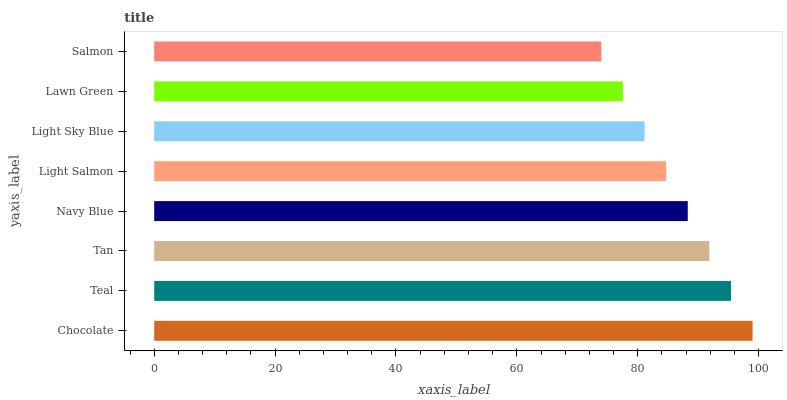Is Salmon the minimum?
Answer yes or no. Yes. Is Chocolate the maximum?
Answer yes or no. Yes. Is Teal the minimum?
Answer yes or no. No. Is Teal the maximum?
Answer yes or no. No. Is Chocolate greater than Teal?
Answer yes or no. Yes. Is Teal less than Chocolate?
Answer yes or no. Yes. Is Teal greater than Chocolate?
Answer yes or no. No. Is Chocolate less than Teal?
Answer yes or no. No. Is Navy Blue the high median?
Answer yes or no. Yes. Is Light Salmon the low median?
Answer yes or no. Yes. Is Tan the high median?
Answer yes or no. No. Is Salmon the low median?
Answer yes or no. No. 